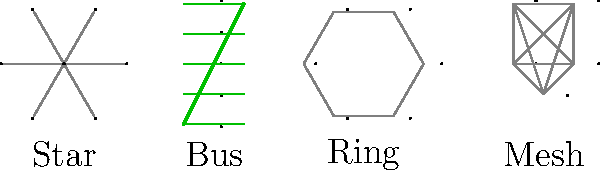As a novelist venturing into technical writing for software startups, you're tasked with explaining network topologies. Which topology would be most resilient to single-point failures and why? To answer this question, let's examine each topology:

1. Star Topology:
   - Central node connects all other nodes
   - Pros: Easy to install and manage
   - Cons: If the central node fails, the entire network fails

2. Bus Topology:
   - All nodes connect to a single cable
   - Pros: Easy to install, uses less cable
   - Cons: If the main cable fails, the entire network fails

3. Ring Topology:
   - Each node connects to two adjacent nodes, forming a ring
   - Pros: Good for small networks, data flows in one direction
   - Cons: If one node fails, it can disrupt the entire network

4. Mesh Topology:
   - Each node connects to multiple other nodes
   - Pros: Highly redundant, multiple paths for data
   - Cons: Complex to set up and manage, requires more cabling

Analyzing these topologies, the mesh topology is the most resilient to single-point failures. Here's why:

1. Redundancy: In a mesh network, each node has multiple connections to other nodes. If one connection fails, data can be rerouted through alternative paths.

2. No single point of failure: Unlike star or bus topologies, there's no central node or cable whose failure would bring down the entire network.

3. Fault tolerance: The network can continue to function even if multiple nodes or connections fail, as long as alternate paths exist.

4. Scalability: New nodes can be added without significantly impacting the network's overall structure or performance.

5. Load balancing: Traffic can be distributed across multiple paths, potentially improving network performance.

For a software startup, especially one dealing with critical data or services, a mesh topology could provide the reliability and redundancy needed to ensure continuous operation, even in the face of hardware failures or network issues.
Answer: Mesh topology 